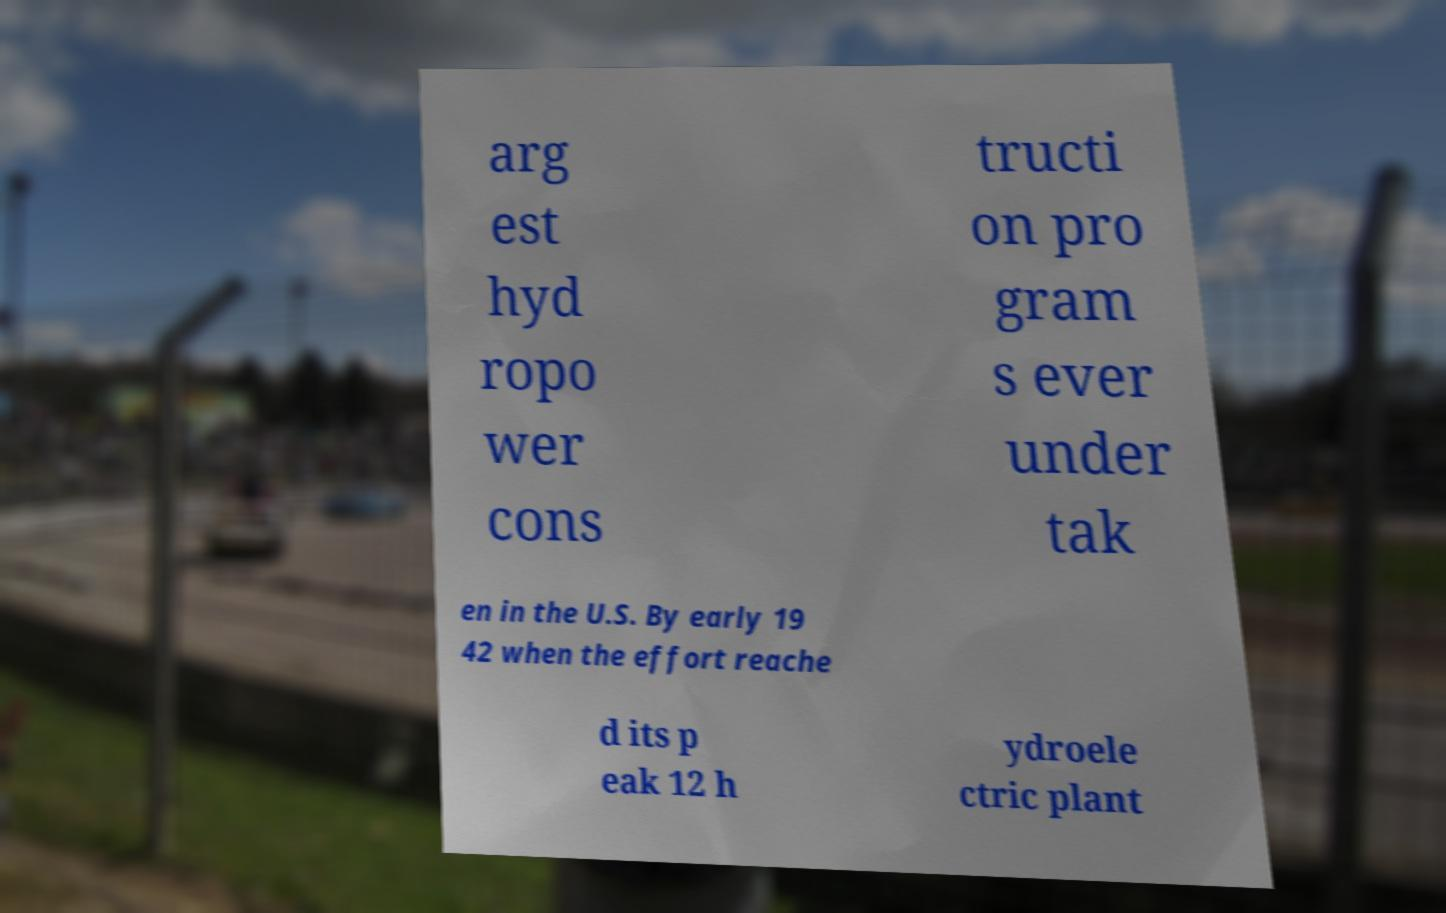Can you accurately transcribe the text from the provided image for me? arg est hyd ropo wer cons tructi on pro gram s ever under tak en in the U.S. By early 19 42 when the effort reache d its p eak 12 h ydroele ctric plant 